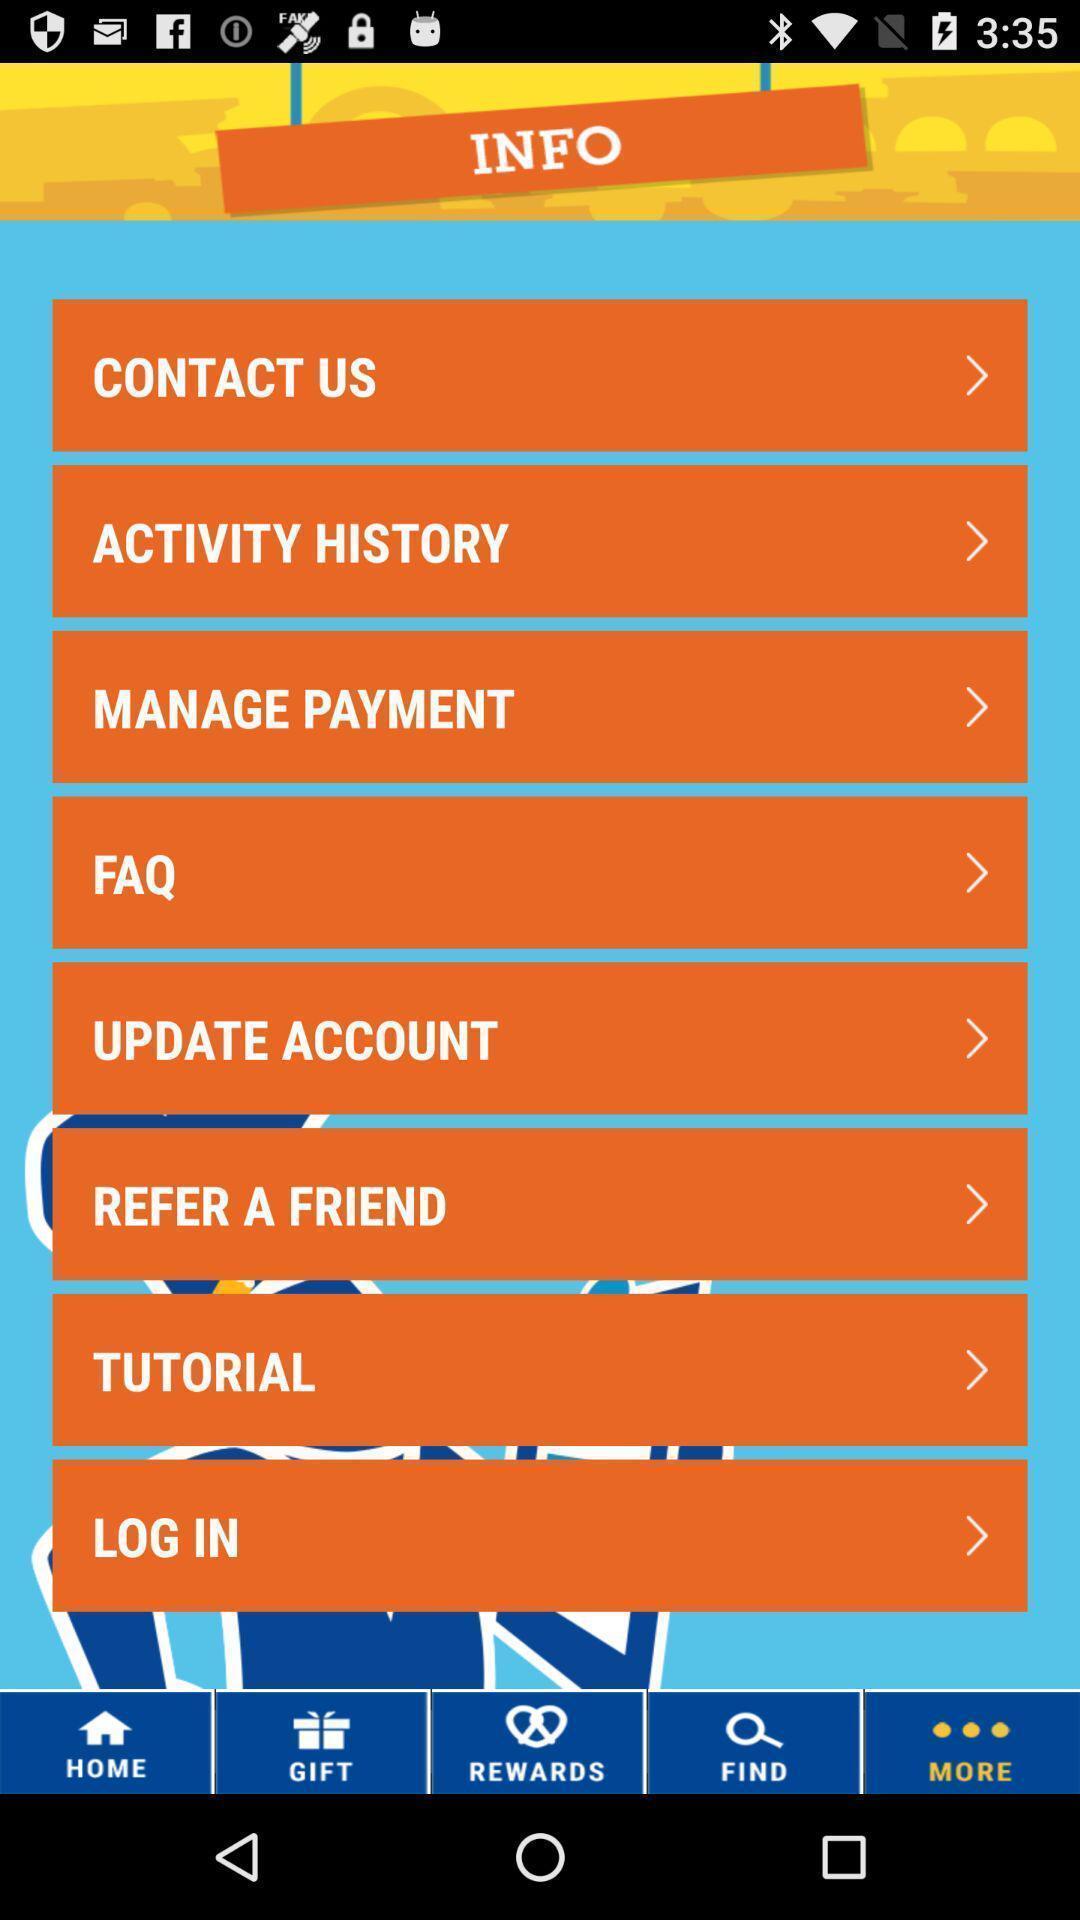Describe this image in words. Page displaying the more options. 